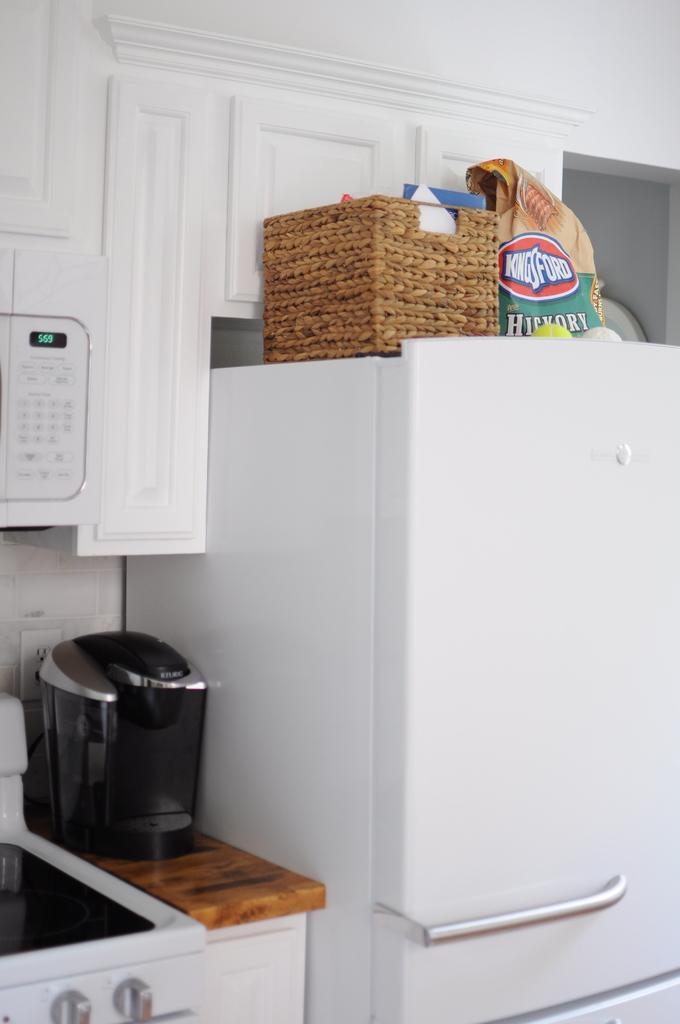<image>
Summarize the visual content of the image. All white kitchen with a Kingsford bag on top of a fridge. 